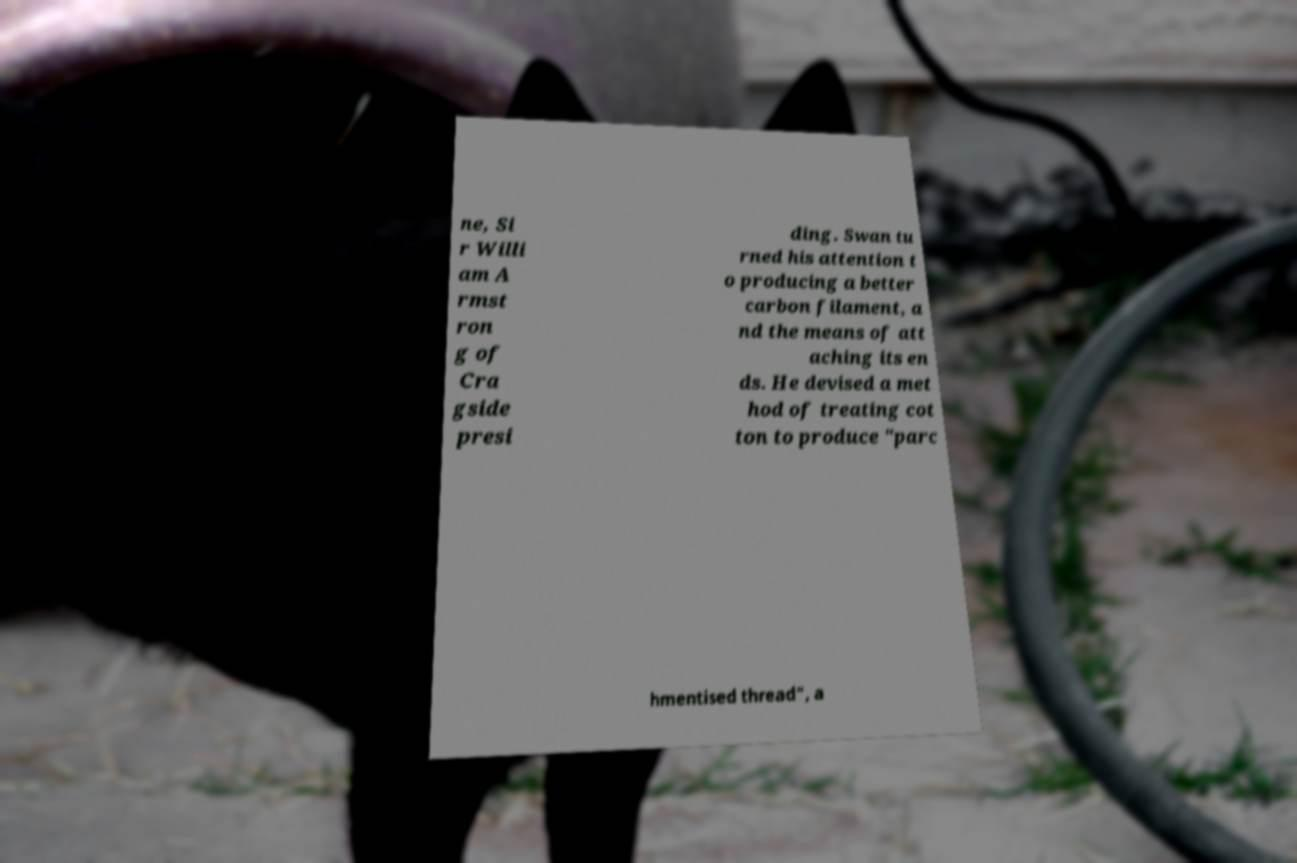Could you assist in decoding the text presented in this image and type it out clearly? ne, Si r Willi am A rmst ron g of Cra gside presi ding. Swan tu rned his attention t o producing a better carbon filament, a nd the means of att aching its en ds. He devised a met hod of treating cot ton to produce "parc hmentised thread", a 